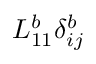Convert formula to latex. <formula><loc_0><loc_0><loc_500><loc_500>L _ { 1 1 } ^ { b } \delta _ { i j } ^ { b }</formula> 